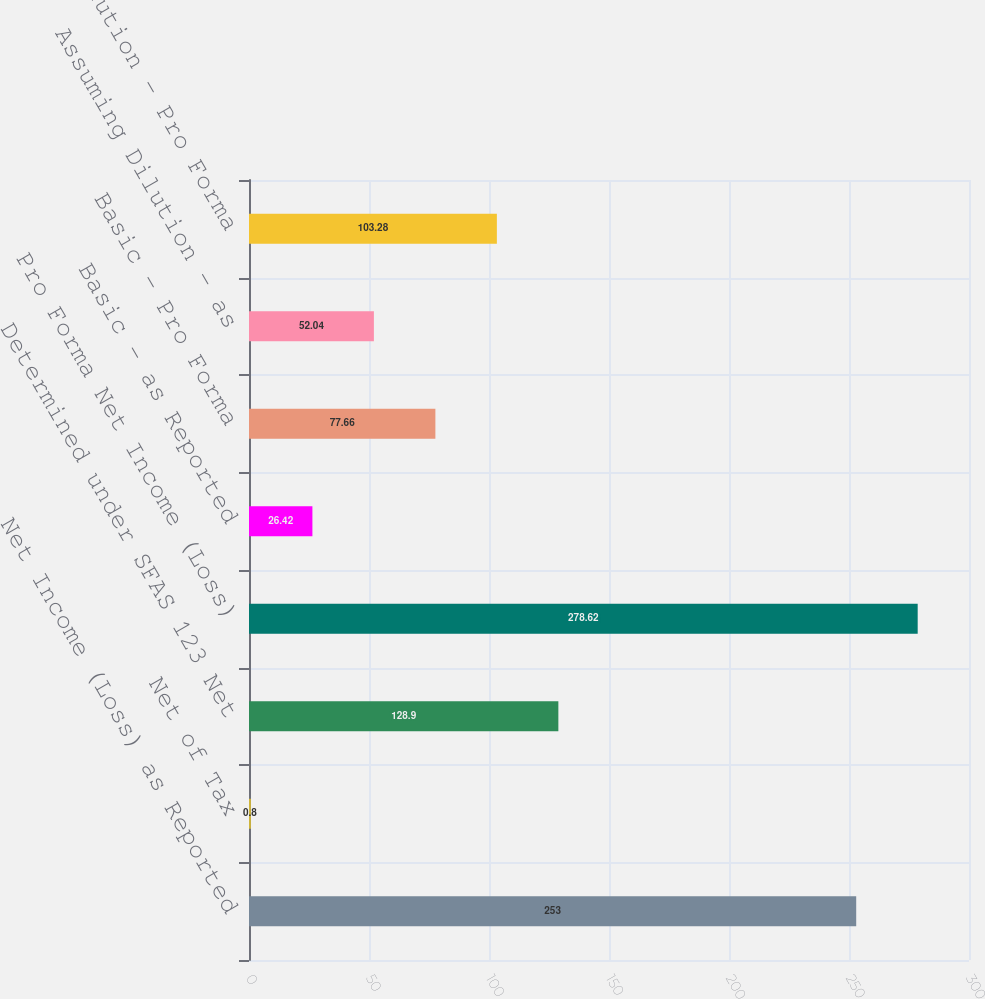Convert chart. <chart><loc_0><loc_0><loc_500><loc_500><bar_chart><fcel>Net Income (Loss) as Reported<fcel>Net of Tax<fcel>Determined under SFAS 123 Net<fcel>Pro Forma Net Income (Loss)<fcel>Basic - as Reported<fcel>Basic - Pro Forma<fcel>Assuming Dilution - as<fcel>Assuming Dilution - Pro Forma<nl><fcel>253<fcel>0.8<fcel>128.9<fcel>278.62<fcel>26.42<fcel>77.66<fcel>52.04<fcel>103.28<nl></chart> 